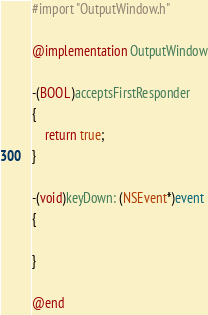<code> <loc_0><loc_0><loc_500><loc_500><_ObjectiveC_>#import "OutputWindow.h"

@implementation OutputWindow

-(BOOL)acceptsFirstResponder
{
	return true;
}

-(void)keyDown: (NSEvent*)event
{

}

@end
</code> 